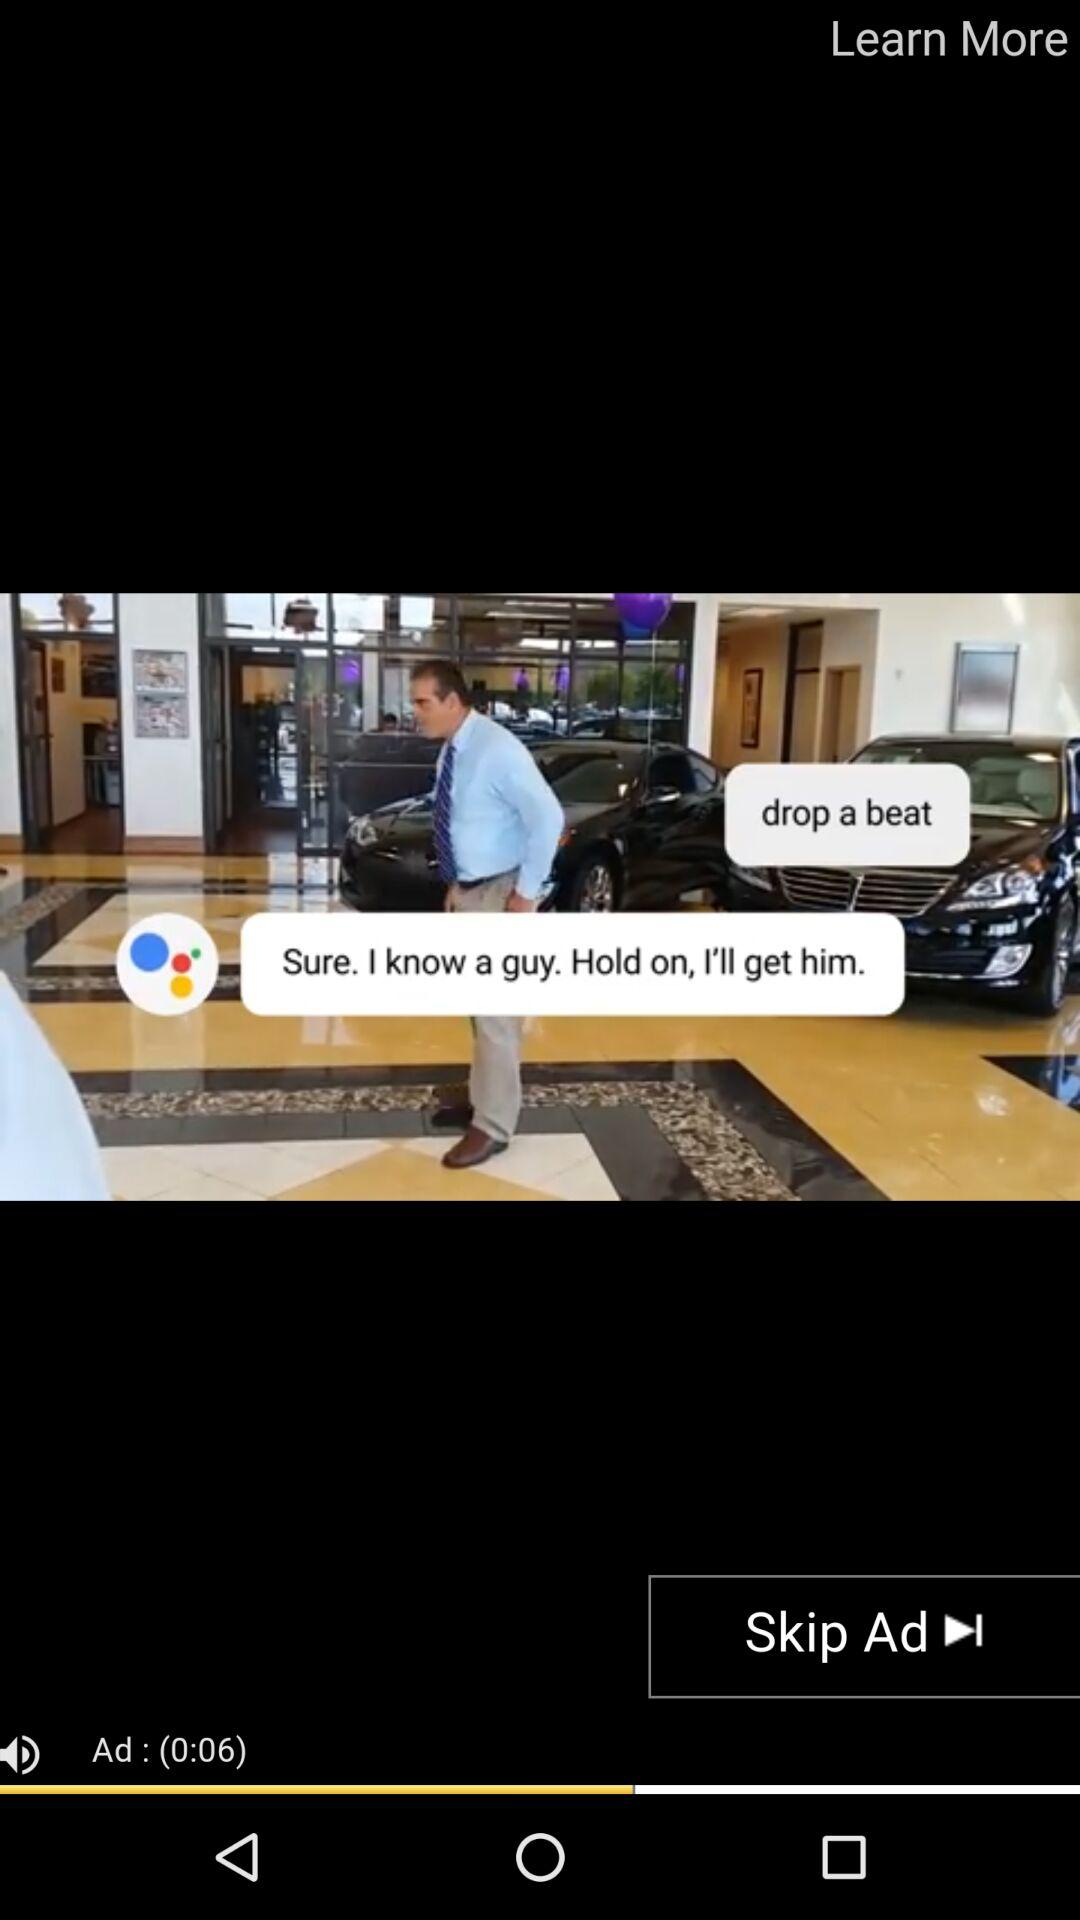How many seconds are left in the ad?
Answer the question using a single word or phrase. 6 